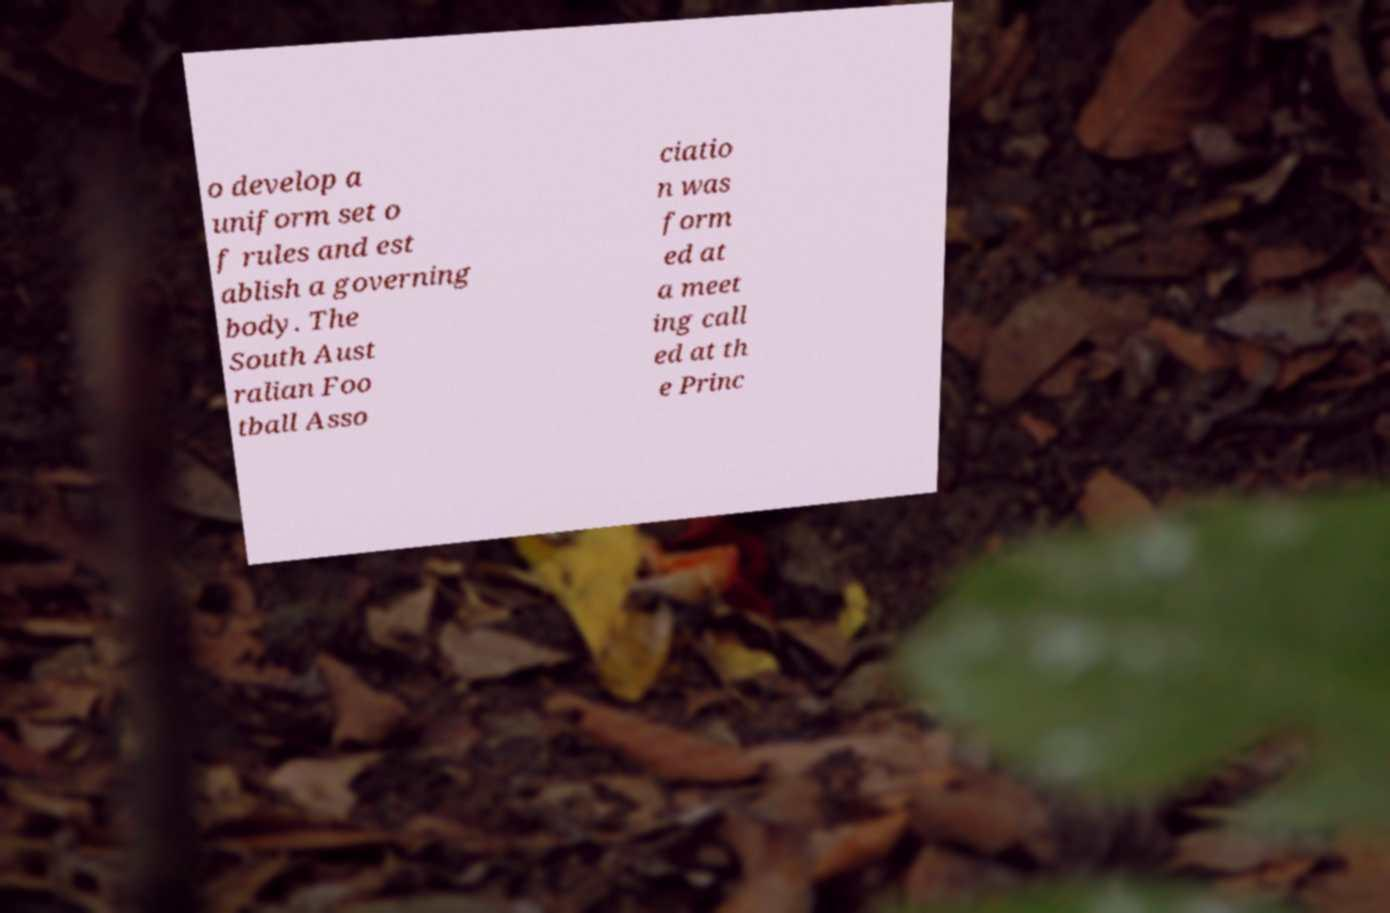For documentation purposes, I need the text within this image transcribed. Could you provide that? o develop a uniform set o f rules and est ablish a governing body. The South Aust ralian Foo tball Asso ciatio n was form ed at a meet ing call ed at th e Princ 